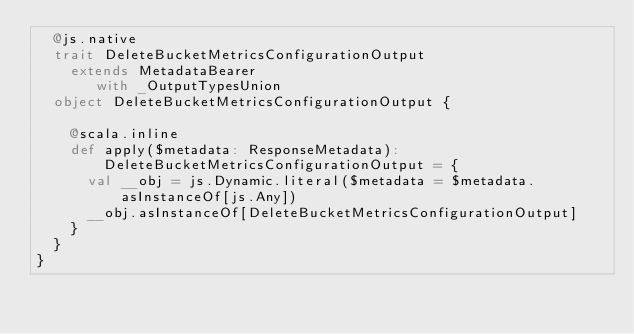Convert code to text. <code><loc_0><loc_0><loc_500><loc_500><_Scala_>  @js.native
  trait DeleteBucketMetricsConfigurationOutput
    extends MetadataBearer
       with _OutputTypesUnion
  object DeleteBucketMetricsConfigurationOutput {
    
    @scala.inline
    def apply($metadata: ResponseMetadata): DeleteBucketMetricsConfigurationOutput = {
      val __obj = js.Dynamic.literal($metadata = $metadata.asInstanceOf[js.Any])
      __obj.asInstanceOf[DeleteBucketMetricsConfigurationOutput]
    }
  }
}
</code> 